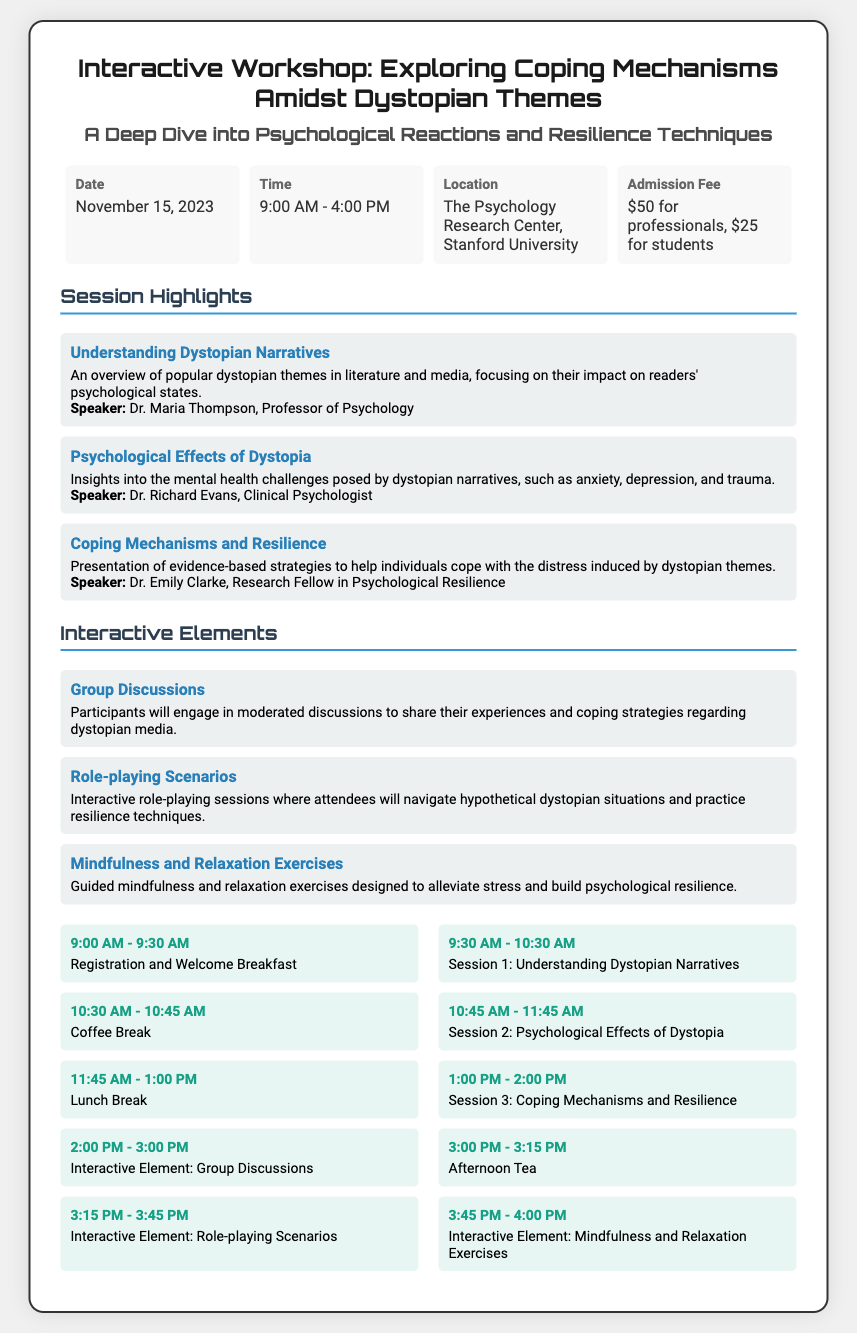What is the date of the workshop? The date of the workshop is explicitly mentioned in the document.
Answer: November 15, 2023 What is the admission fee for professionals? The admission fee for professionals is listed in the document, specifying different fees for different groups.
Answer: $50 for professionals Who is the speaker for the session on psychological effects of dystopia? The speaker's name for the relevant session is directly mentioned in the session highlights.
Answer: Dr. Richard Evans How long is the coffee break? The coffee break duration can be calculated by knowing the session schedule.
Answer: 15 minutes What time does the workshop start? The starting time of the workshop is explicitly stated in the document.
Answer: 9:00 AM What interactive element involves role-playing? The document lists various interactive elements, and this one is clearly identified.
Answer: Role-playing Scenarios What is discussed in the session on coping mechanisms? The content of the session is outlined in the document's session highlights.
Answer: Evidence-based strategies to cope with distress How many total sessions are listed in the highlights? By counting the sessions explicitly described in the document, the total can be determined.
Answer: Three sessions What is the location of the workshop? The location of the workshop is directly provided in the document.
Answer: The Psychology Research Center, Stanford University What is included in the morning schedule? The document details the activities scheduled for the morning, specifically mentioning registration and sessions.
Answer: Registration and Welcome Breakfast; Session 1: Understanding Dystopian Narratives 